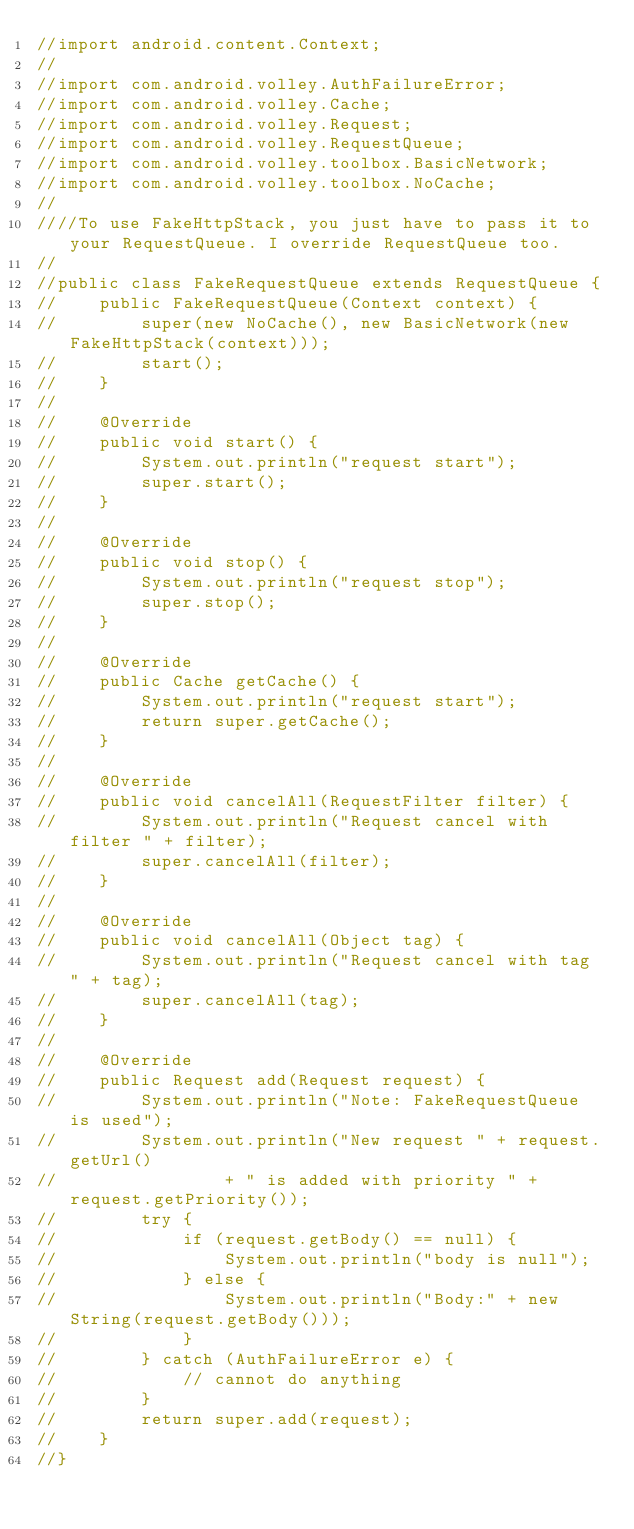<code> <loc_0><loc_0><loc_500><loc_500><_Java_>//import android.content.Context;
//
//import com.android.volley.AuthFailureError;
//import com.android.volley.Cache;
//import com.android.volley.Request;
//import com.android.volley.RequestQueue;
//import com.android.volley.toolbox.BasicNetwork;
//import com.android.volley.toolbox.NoCache;
//
////To use FakeHttpStack, you just have to pass it to your RequestQueue. I override RequestQueue too.
//
//public class FakeRequestQueue extends RequestQueue {
//    public FakeRequestQueue(Context context) {
//        super(new NoCache(), new BasicNetwork(new FakeHttpStack(context)));
//        start();
//    }
//
//    @Override
//    public void start() {
//        System.out.println("request start");
//        super.start();
//    }
//
//    @Override
//    public void stop() {
//        System.out.println("request stop");
//        super.stop();
//    }
//
//    @Override
//    public Cache getCache() {
//        System.out.println("request start");
//        return super.getCache();
//    }
//
//    @Override
//    public void cancelAll(RequestFilter filter) {
//        System.out.println("Request cancel with filter " + filter);
//        super.cancelAll(filter);
//    }
//
//    @Override
//    public void cancelAll(Object tag) {
//        System.out.println("Request cancel with tag " + tag);
//        super.cancelAll(tag);
//    }
//
//    @Override
//    public Request add(Request request) {
//        System.out.println("Note: FakeRequestQueue is used");
//        System.out.println("New request " + request.getUrl()
//                + " is added with priority " + request.getPriority());
//        try {
//            if (request.getBody() == null) {
//                System.out.println("body is null");
//            } else {
//                System.out.println("Body:" + new String(request.getBody()));
//            }
//        } catch (AuthFailureError e) {
//            // cannot do anything
//        }
//        return super.add(request);
//    }
//}
</code> 